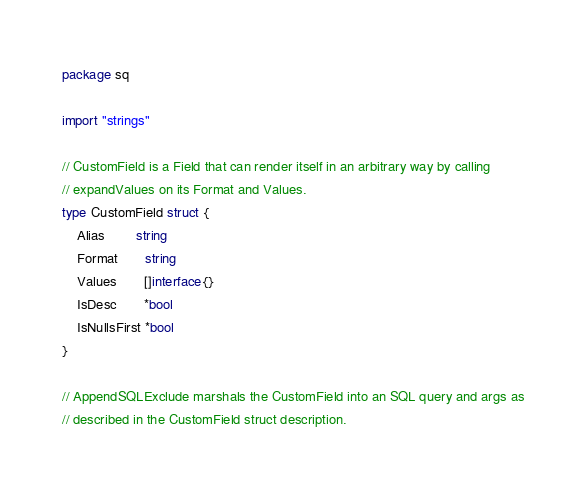<code> <loc_0><loc_0><loc_500><loc_500><_Go_>package sq

import "strings"

// CustomField is a Field that can render itself in an arbitrary way by calling
// expandValues on its Format and Values.
type CustomField struct {
	Alias        string
	Format       string
	Values       []interface{}
	IsDesc       *bool
	IsNullsFirst *bool
}

// AppendSQLExclude marshals the CustomField into an SQL query and args as
// described in the CustomField struct description.</code> 